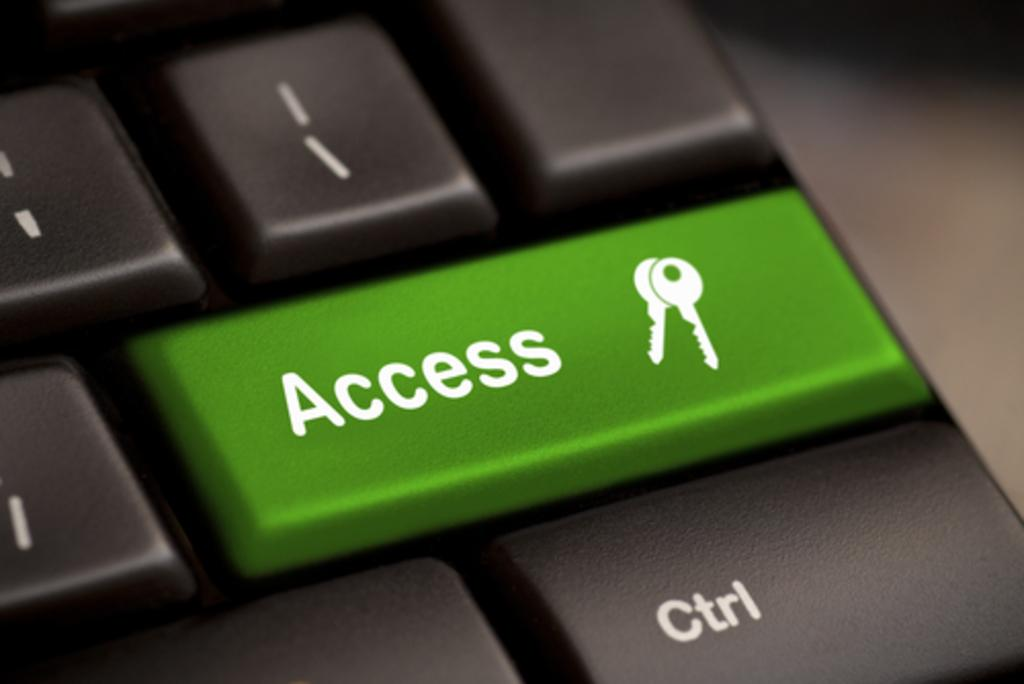<image>
Describe the image concisely. black keyboard with a green access key sit on the desk 